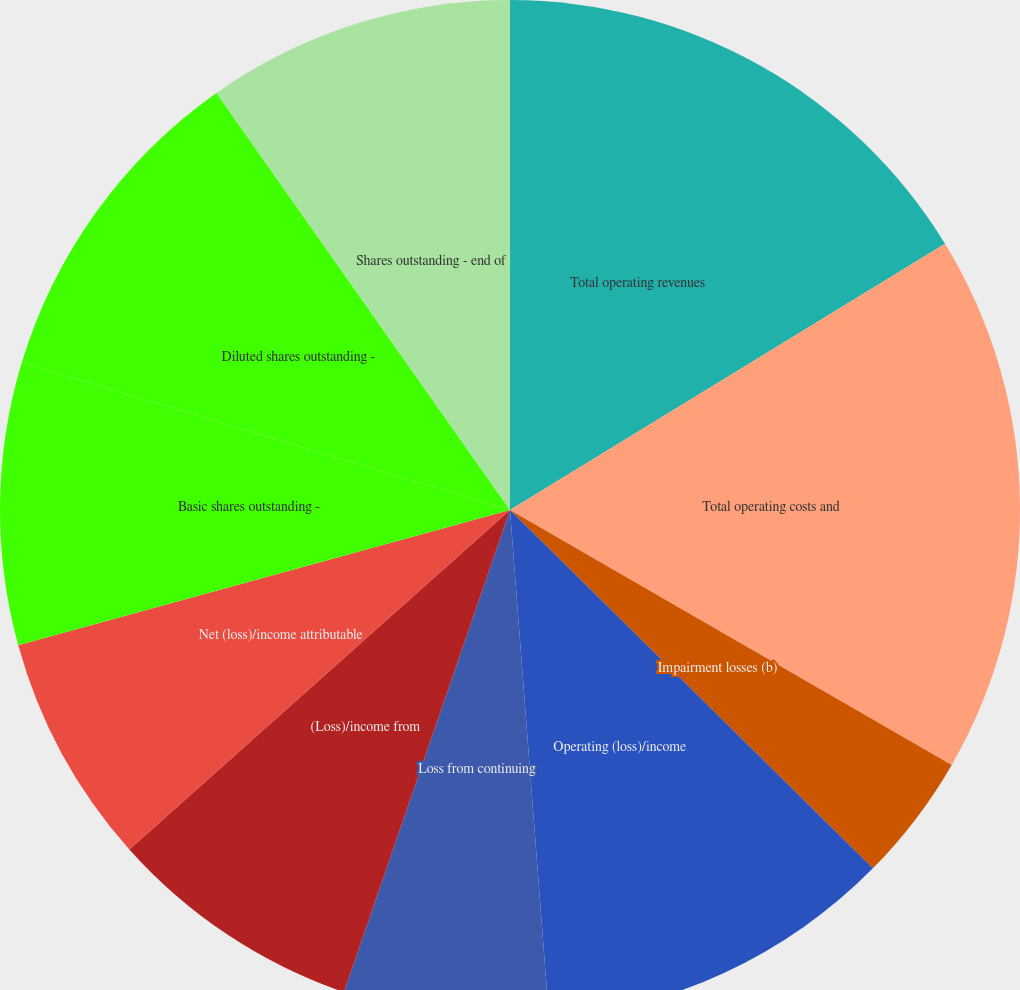Convert chart to OTSL. <chart><loc_0><loc_0><loc_500><loc_500><pie_chart><fcel>Total operating revenues<fcel>Total operating costs and<fcel>Impairment losses (b)<fcel>Operating (loss)/income<fcel>Loss from continuing<fcel>(Loss)/income from<fcel>Net (loss)/income attributable<fcel>Basic shares outstanding -<fcel>Diluted shares outstanding -<fcel>Shares outstanding - end of<nl><fcel>16.26%<fcel>17.07%<fcel>4.07%<fcel>11.38%<fcel>6.5%<fcel>8.13%<fcel>7.32%<fcel>8.94%<fcel>10.57%<fcel>9.76%<nl></chart> 